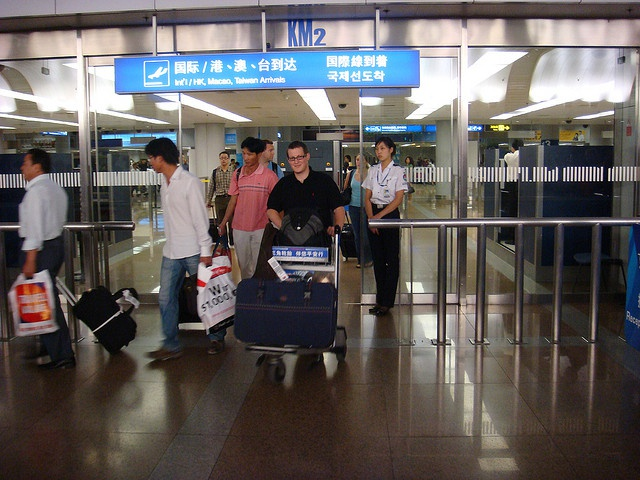Describe the objects in this image and their specific colors. I can see people in gray, darkgray, and black tones, suitcase in gray and black tones, people in gray, black, darkgray, and maroon tones, people in gray, black, darkgray, and brown tones, and people in gray, brown, maroon, and black tones in this image. 